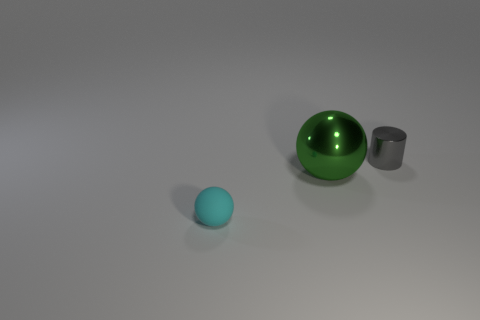There is a large thing that is made of the same material as the small gray cylinder; what is its shape?
Provide a short and direct response. Sphere. Is the color of the ball that is on the right side of the small sphere the same as the shiny object on the right side of the big thing?
Your response must be concise. No. Is the number of tiny cyan rubber objects that are behind the small cyan object the same as the number of small purple matte cylinders?
Your response must be concise. Yes. There is a large shiny thing; what number of objects are right of it?
Your response must be concise. 1. What is the size of the green metal ball?
Offer a very short reply. Large. What is the color of the cylinder that is the same material as the green object?
Your response must be concise. Gray. How many matte spheres have the same size as the gray shiny object?
Your response must be concise. 1. Is the material of the tiny object that is to the right of the tiny ball the same as the large object?
Your answer should be very brief. Yes. Are there fewer spheres right of the green metal sphere than cyan rubber balls?
Make the answer very short. Yes. What is the shape of the small object that is behind the small rubber ball?
Make the answer very short. Cylinder. 